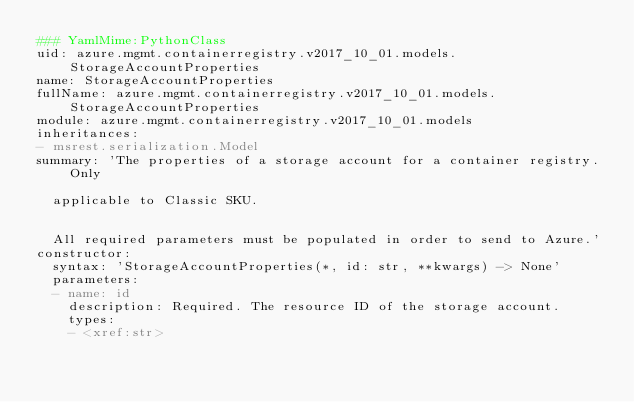<code> <loc_0><loc_0><loc_500><loc_500><_YAML_>### YamlMime:PythonClass
uid: azure.mgmt.containerregistry.v2017_10_01.models.StorageAccountProperties
name: StorageAccountProperties
fullName: azure.mgmt.containerregistry.v2017_10_01.models.StorageAccountProperties
module: azure.mgmt.containerregistry.v2017_10_01.models
inheritances:
- msrest.serialization.Model
summary: 'The properties of a storage account for a container registry. Only

  applicable to Classic SKU.


  All required parameters must be populated in order to send to Azure.'
constructor:
  syntax: 'StorageAccountProperties(*, id: str, **kwargs) -> None'
  parameters:
  - name: id
    description: Required. The resource ID of the storage account.
    types:
    - <xref:str>
</code> 